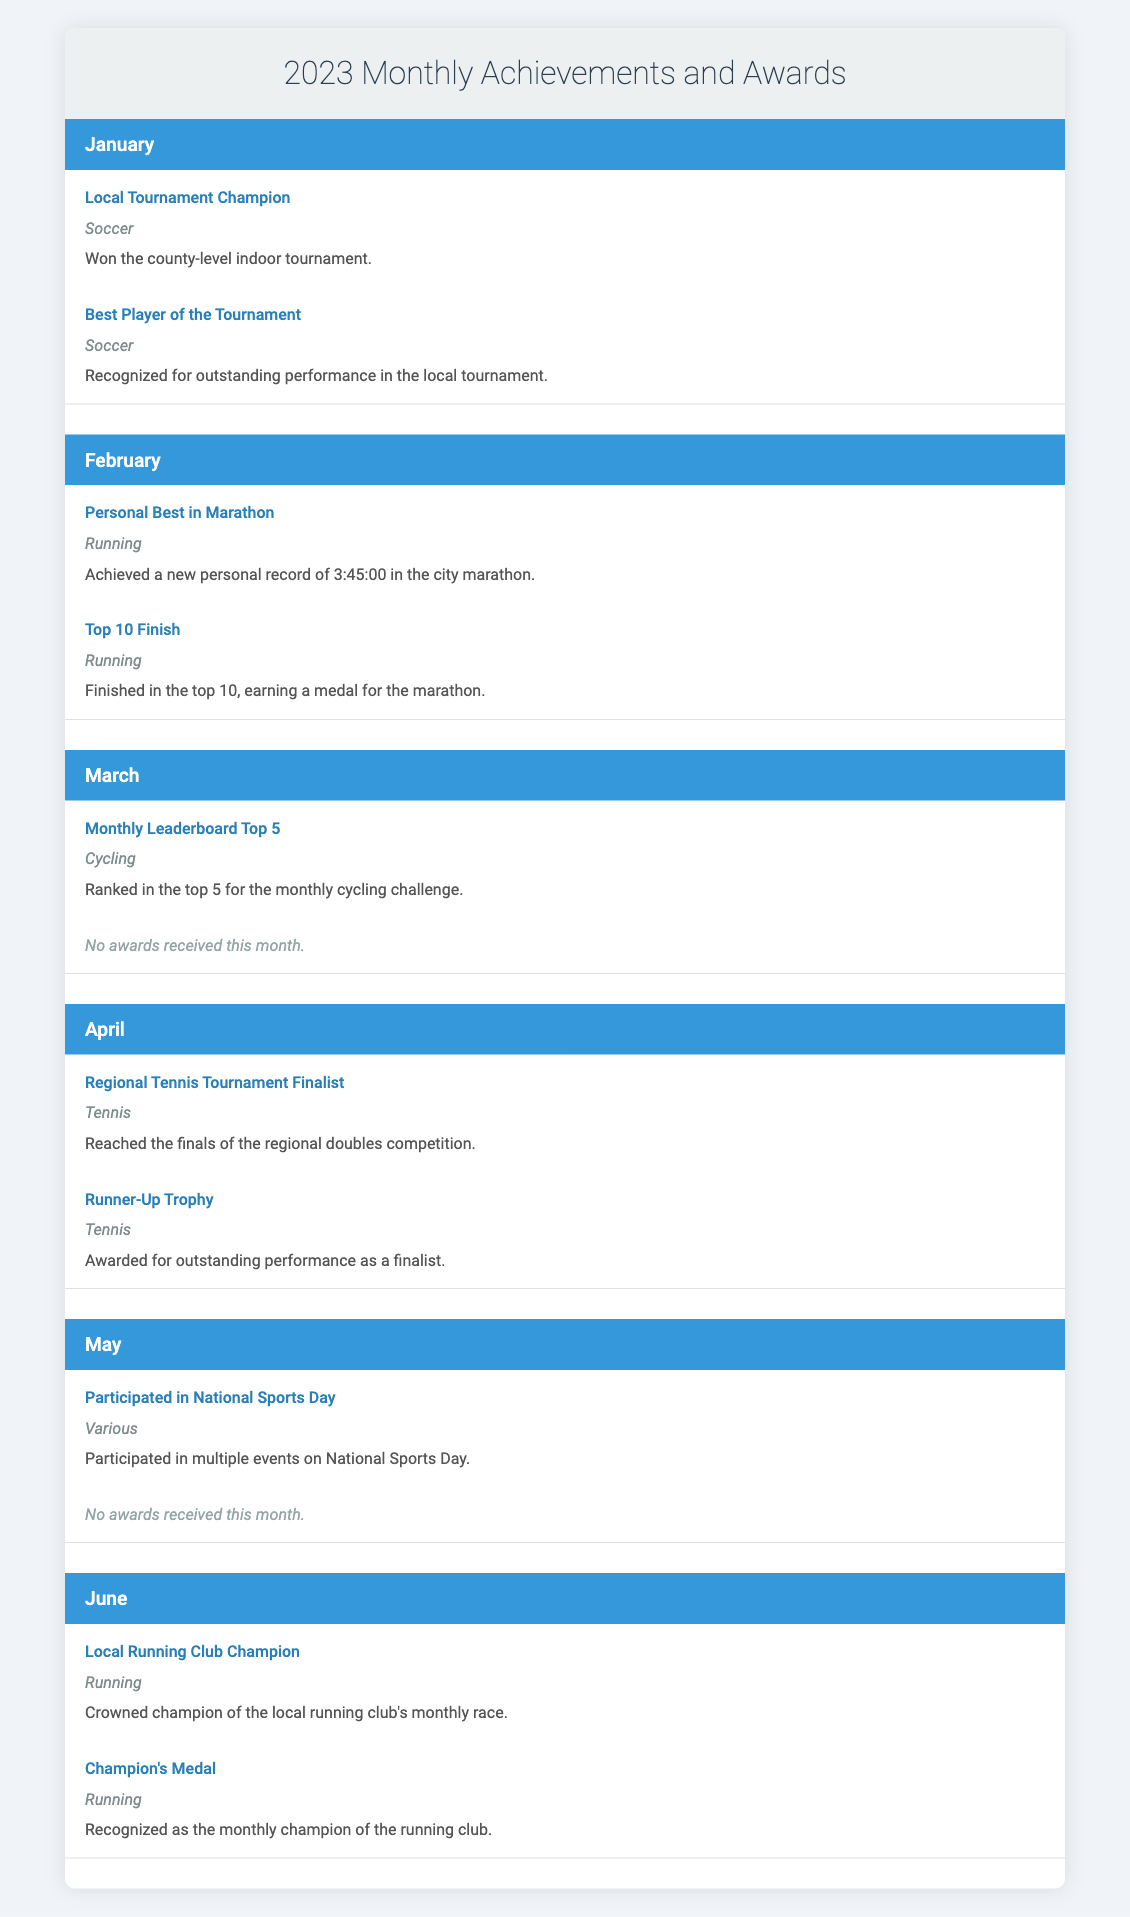What was the achievement in June? In June, the achievement listed is "Local Running Club Champion" in Running, where the individual crowned champion of the local running club's monthly race.
Answer: Local Running Club Champion How many months received awards in 2023? Awards were received in January (Best Player of the Tournament), April (Runner-Up Trophy), and June (Champion's Medal), totaling three months.
Answer: 3 Did you receive any awards in May? In May, the recorded data indicates "No awards received this month," confirming that no awards were earned.
Answer: No What sport was featured in the February achievement and award? The achievement and award in February both pertain to Running, as the individual achieved a personal best and finished in the top 10 of the marathon.
Answer: Running Which month had the highest number of achievements and awards combined? The highest number of achievements and awards is in June, with one achievement and one award. April also has one achievement and one award, but they are tied.
Answer: June and April (tie) 